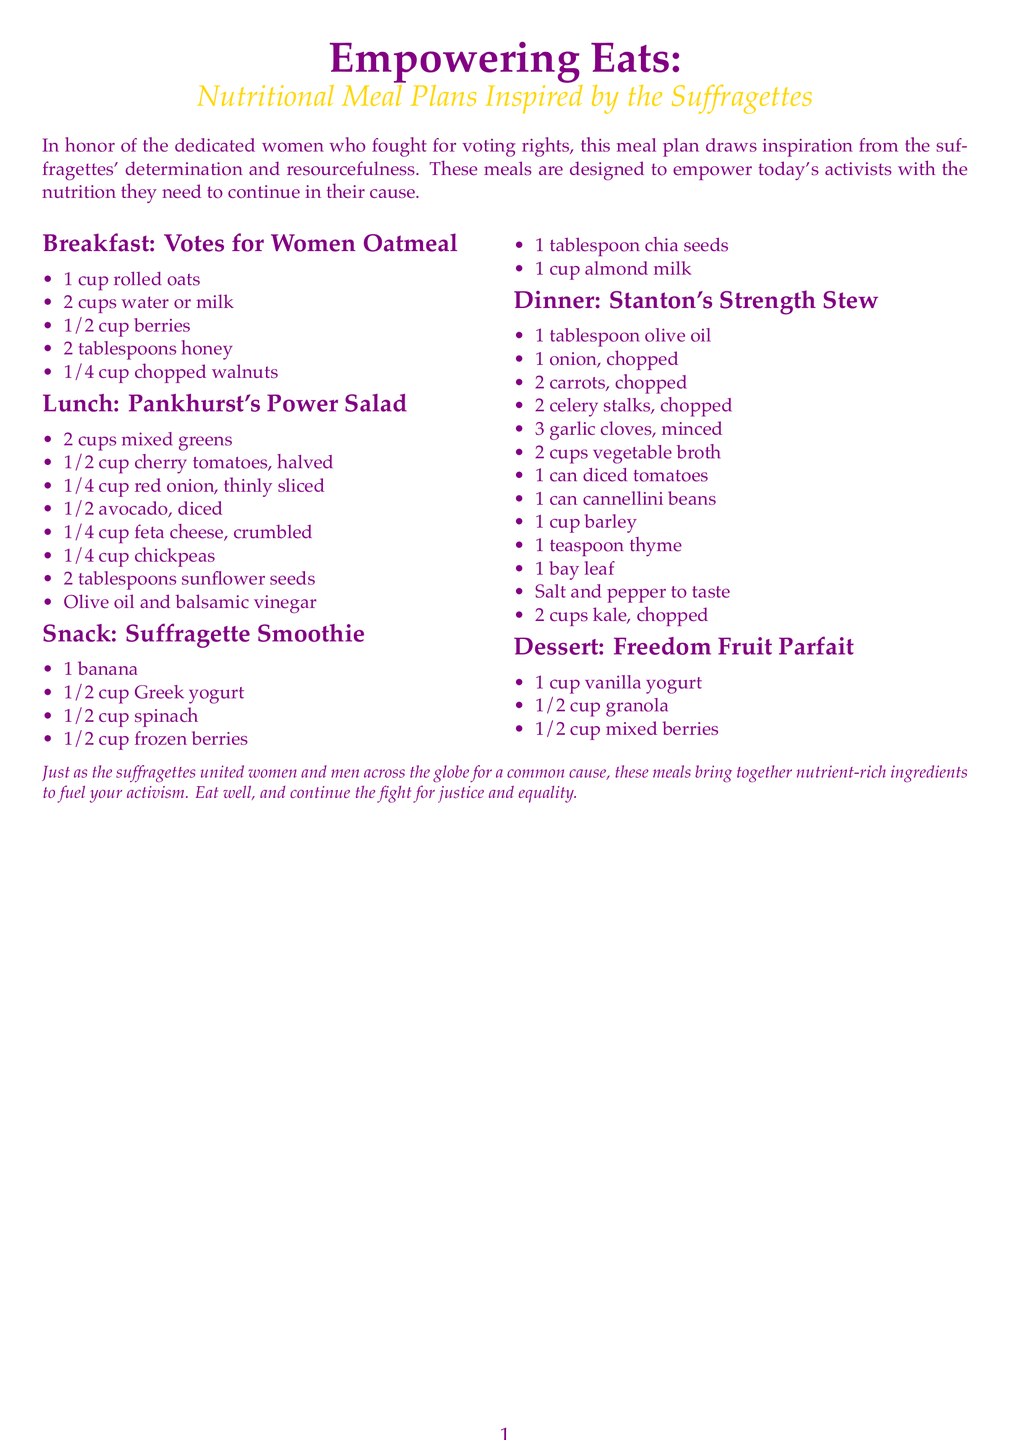What is the title of the meal plan? The title of the meal plan is prominently displayed at the top of the document.
Answer: Empowering Eats How many cups of mixed greens are in the lunch recipe? The lunch recipe specifies the quantity of mixed greens needed.
Answer: 2 cups What is the main ingredient in the Suffragette Smoothie? The main ingredient, along with others, is highlighted in the snack section of the meal plan.
Answer: Banana Which meal includes chickpeas? The meal that features chickpeas is mentioned in the lunch section.
Answer: Pankhurst's Power Salad What type of broth is used in Stanton's Strength Stew? The type of broth is listed clearly within the dinner recipe.
Answer: Vegetable broth How many tablespoons of honey are needed for breakfast? The breakfast recipe lists the quantity of honey explicitly.
Answer: 2 tablespoons What is the dessert item in the meal plan? The dessert item is clearly named in the last meal section.
Answer: Freedom Fruit Parfait Which meal corresponds with the name of a suffragist? The dinner meal is named after a notable individual recognized for their contributions.
Answer: Stanton's Strength Stew How many ingredients are listed for the breakfast oatmeal? The number of ingredients for the breakfast item is provided in a simple list format.
Answer: 5 ingredients 